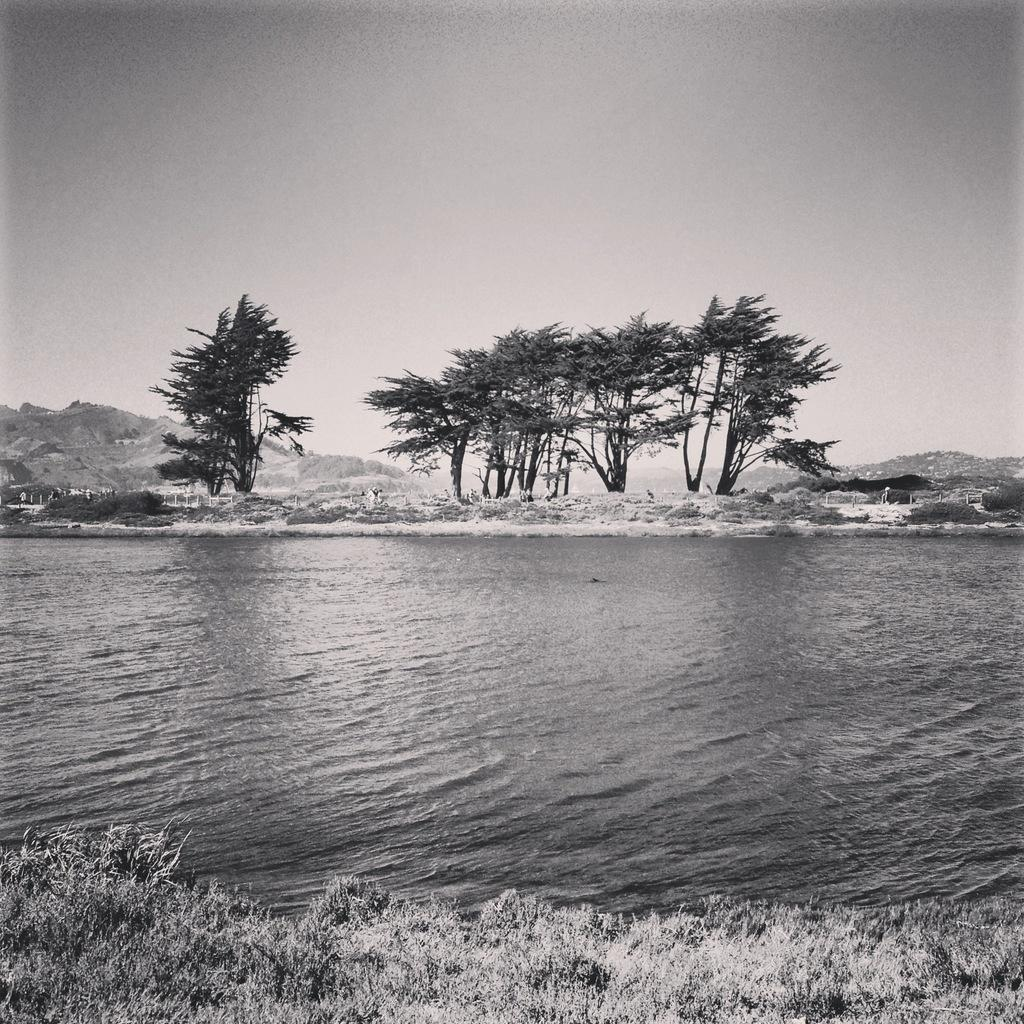What is visible at the bottom of the image? There is water visible at the bottom of the image. What type of vegetation can be seen in the middle of the image? There are trees in the middle of the image. What is visible at the top of the image? The sky is visible at the top of the image. What direction is the stamp facing in the image? There is no stamp present in the image. What type of test is being conducted in the image? There is no test being conducted in the image. 